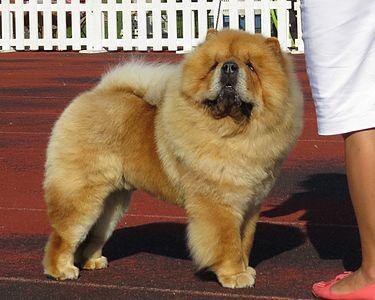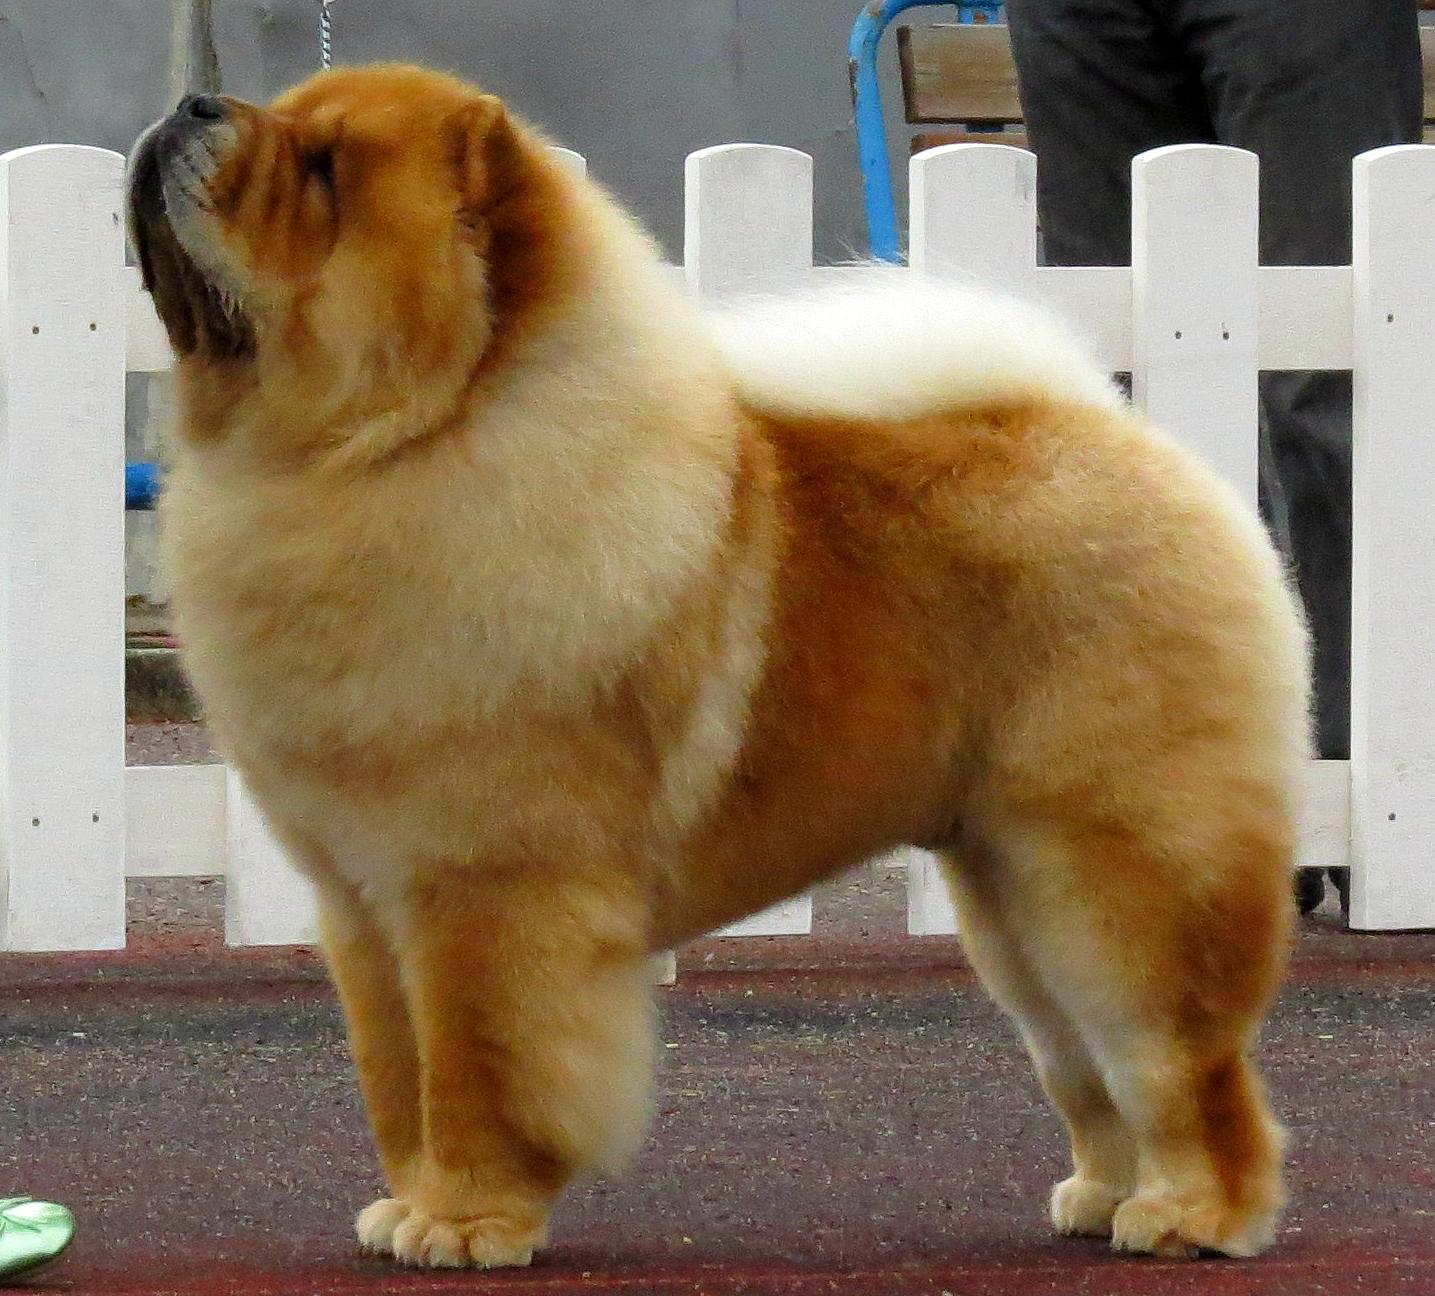The first image is the image on the left, the second image is the image on the right. Evaluate the accuracy of this statement regarding the images: "Right image shows a chow dog standing with its body turned leftward.". Is it true? Answer yes or no. Yes. The first image is the image on the left, the second image is the image on the right. Examine the images to the left and right. Is the description "At least one of the furry dogs is standing in the grass." accurate? Answer yes or no. No. 